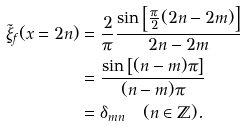<formula> <loc_0><loc_0><loc_500><loc_500>\tilde { \xi } _ { f } ( x = 2 n ) & = \frac { 2 } { \pi } \frac { \sin \left [ \frac { \pi } { 2 } ( 2 n - 2 m ) \right ] } { 2 n - 2 m } \\ & = \frac { \sin \left [ ( n - m ) \pi \right ] } { ( n - m ) \pi } \\ & = \delta _ { m n } \quad ( n \in \mathbb { Z } ) .</formula> 